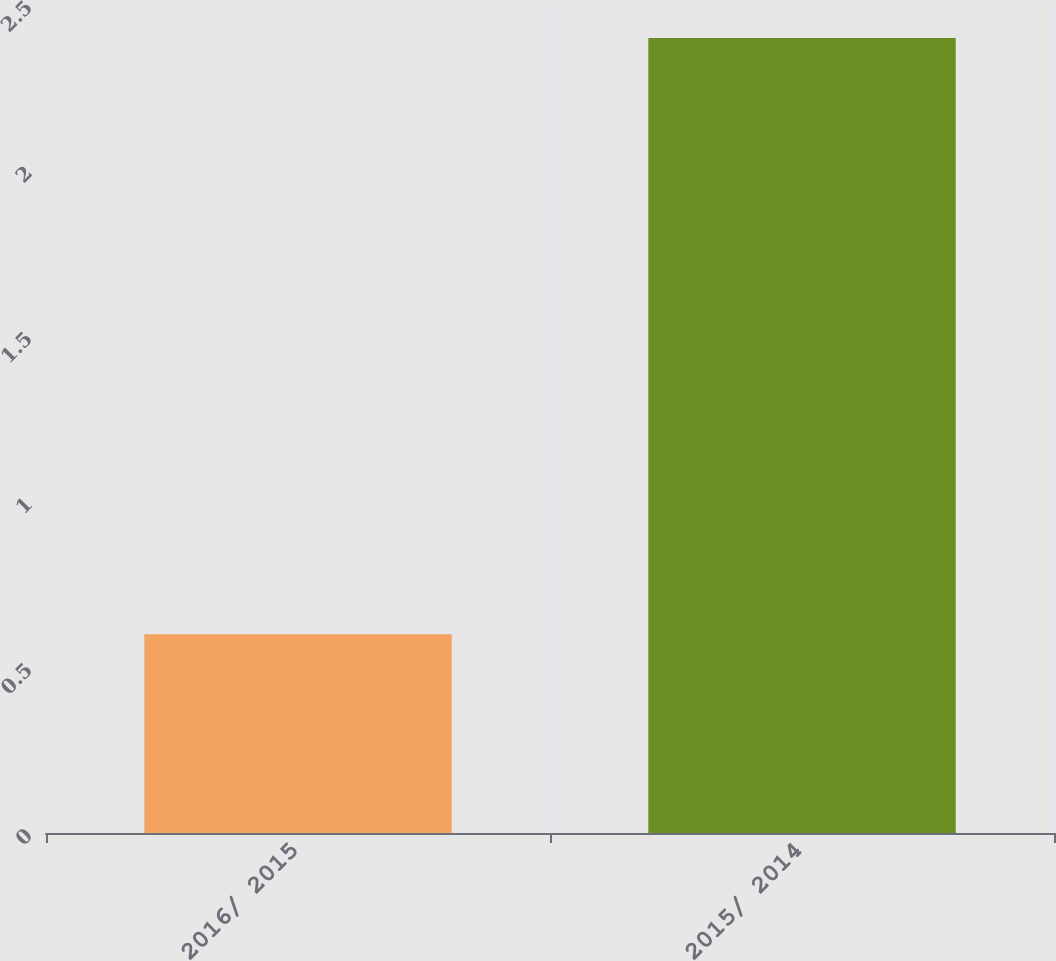Convert chart to OTSL. <chart><loc_0><loc_0><loc_500><loc_500><bar_chart><fcel>2016/ 2015<fcel>2015/ 2014<nl><fcel>0.6<fcel>2.4<nl></chart> 